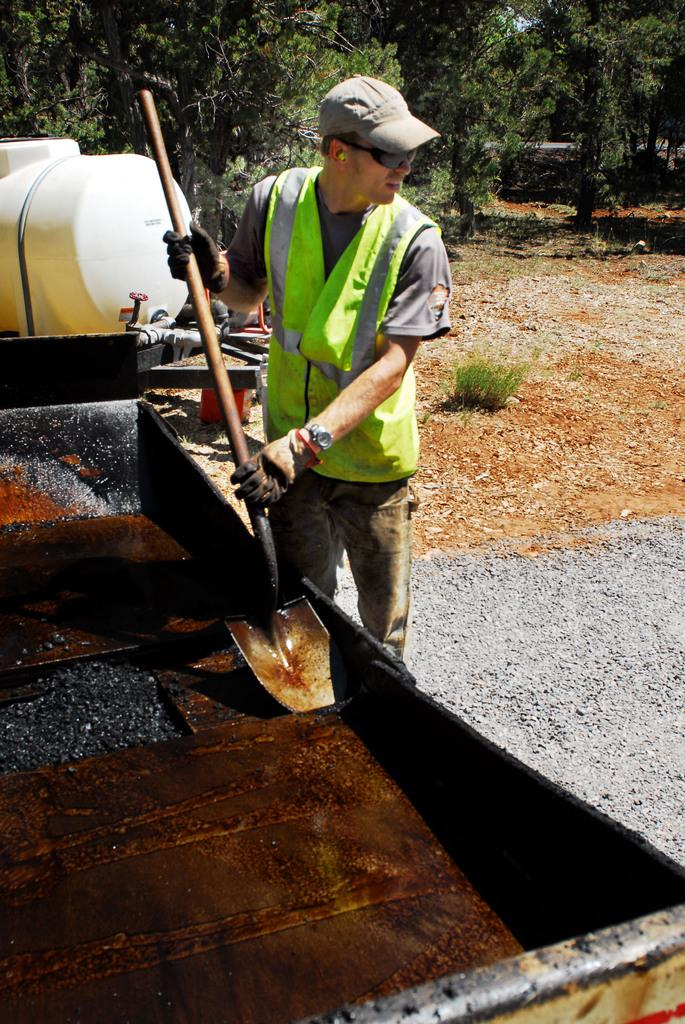Who is present in the image? There is a man in the image. What is the man holding in the image? The man is holding a spade. What is the man wearing on his upper body? The man is wearing a green coat. What type of headwear is the man wearing? The man is wearing a cap. What can be seen in the background of the image? There are trees in the background of the image. What brand of toothpaste is the man using in the image? There is no toothpaste present in the image, and the man is not using any toothpaste. How long has the man been resting in the image? The man is not resting in the image; he is holding a spade and wearing a green coat and cap. 